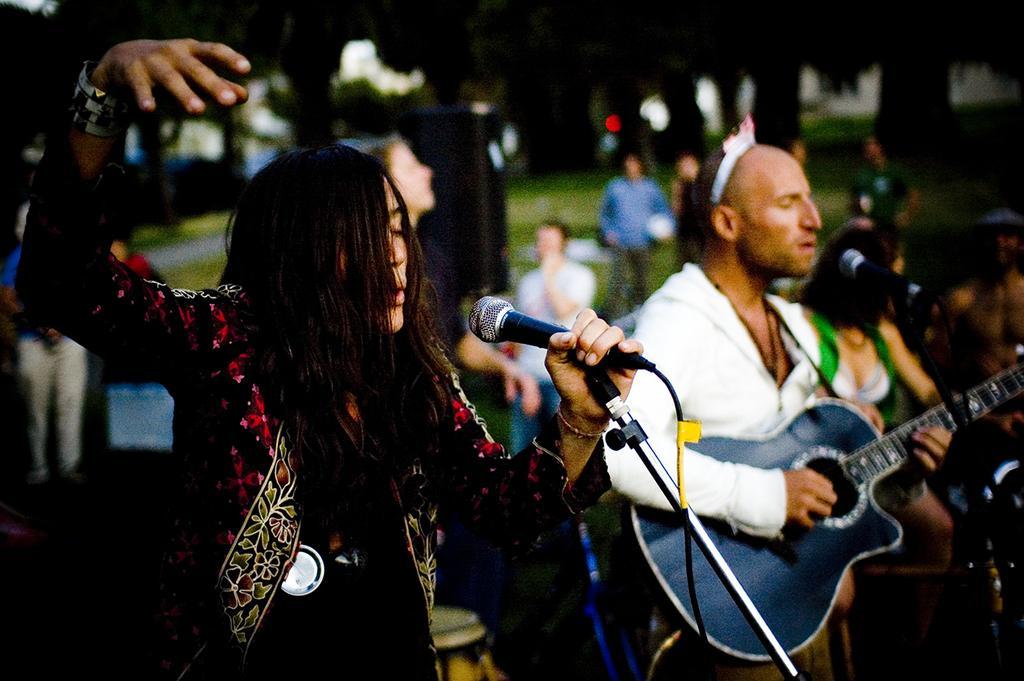Can you describe this image briefly? In the image there is a woman standing and holding a microphone for singing. On right side there is a man wearing a white color shirt holding a guitar and playing it in front of a microphone, in background we can see few people,trees. 